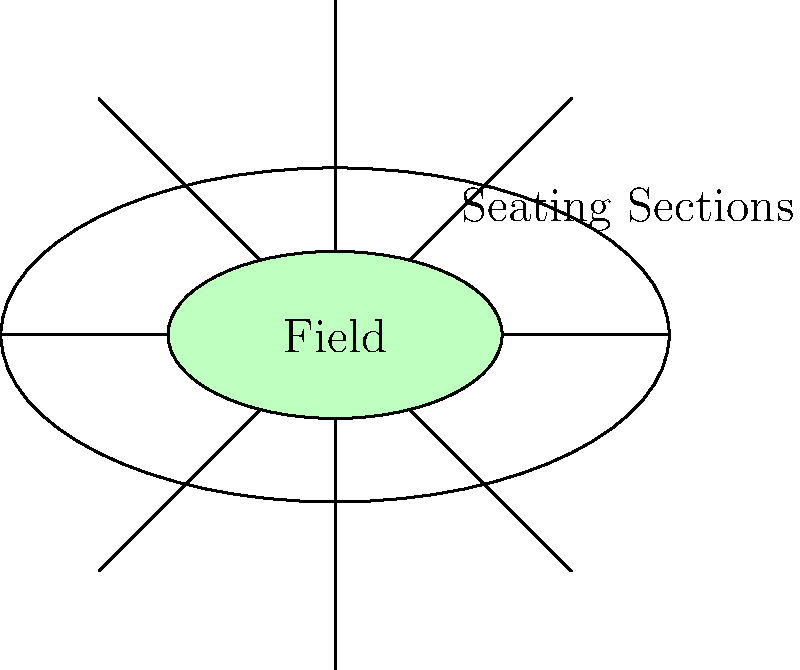You're designing a new football stadium for your next music video collaboration. The seating arrangement is divided into 8 sections, as shown in the diagram. Each section is separated by aisles, and there's a central field. How many vertices (V), edges (E), and faces (F) are in this arrangement, and what is the Euler characteristic ($\chi$) of the stadium's topology? Let's break this down step-by-step:

1. Count the vertices (V):
   - 8 intersections where the aisles meet the outer edge
   - 8 intersections where the aisles meet the inner edge (field)
   - Total vertices: V = 16

2. Count the edges (E):
   - 8 outer edges (between sections on the stadium perimeter)
   - 8 inner edges (between sections on the field perimeter)
   - 8 aisle edges
   - Total edges: E = 24

3. Count the faces (F):
   - 8 seating sections
   - 1 central field
   - Total faces: F = 9

4. Calculate the Euler characteristic ($\chi$):
   The formula for Euler characteristic is: $\chi = V - E + F$
   
   Substituting our values:
   $\chi = 16 - 24 + 9 = 1$

The Euler characteristic of 1 indicates that this stadium topology is equivalent to a disk or a plane, which makes sense given its open-air nature.
Answer: V = 16, E = 24, F = 9, $\chi = 1$ 